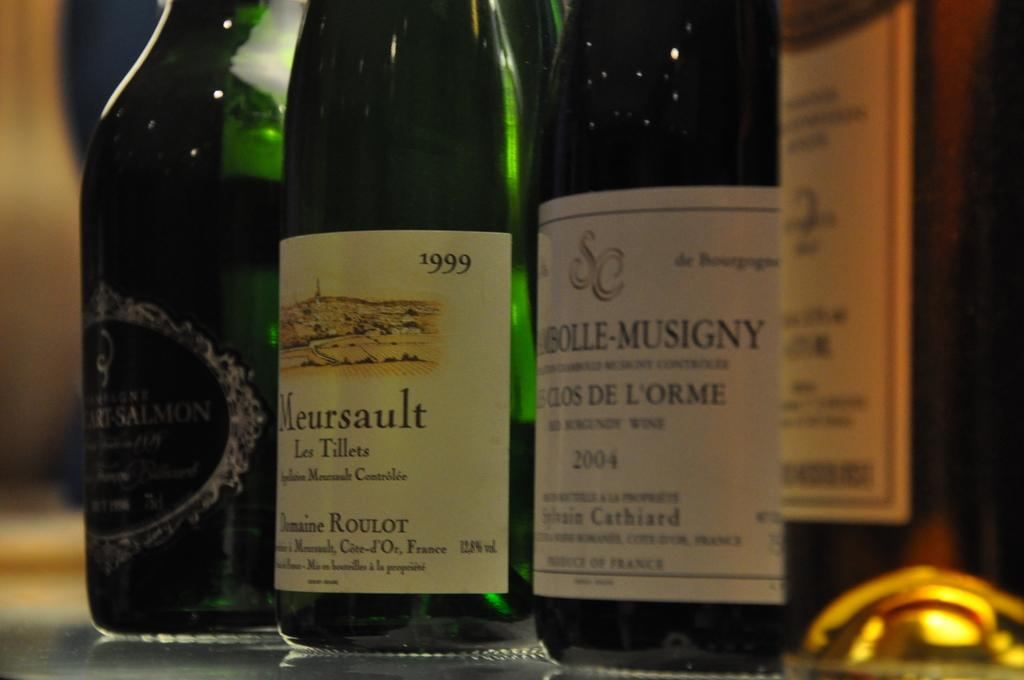<image>
Create a compact narrative representing the image presented. A bottle of Meursault from the year 1999 amongst other bottles. 